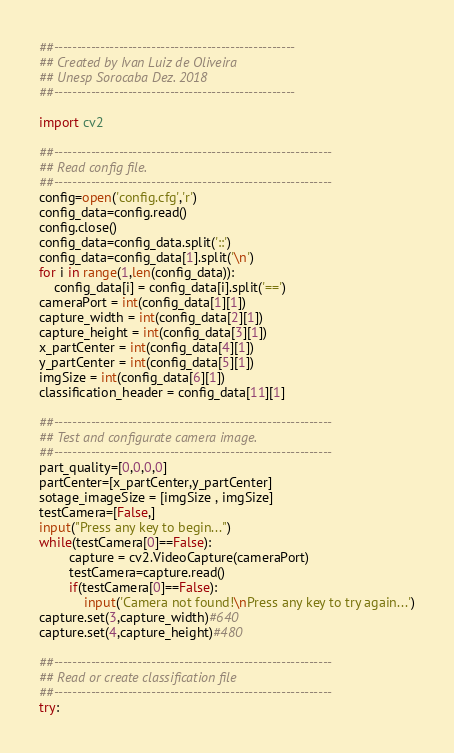Convert code to text. <code><loc_0><loc_0><loc_500><loc_500><_Python_>##----------------------------------------------------
## Created by Ivan Luiz de Oliveira
## Unesp Sorocaba Dez. 2018
##----------------------------------------------------

import cv2

##------------------------------------------------------------
## Read config file.
##------------------------------------------------------------
config=open('config.cfg','r')
config_data=config.read()
config.close()
config_data=config_data.split('::')
config_data=config_data[1].split('\n')
for i in range(1,len(config_data)):
    config_data[i] = config_data[i].split('==')
cameraPort = int(config_data[1][1])
capture_width = int(config_data[2][1])
capture_height = int(config_data[3][1])
x_partCenter = int(config_data[4][1])
y_partCenter = int(config_data[5][1])
imgSize = int(config_data[6][1])
classification_header = config_data[11][1]

##------------------------------------------------------------
## Test and configurate camera image.
##------------------------------------------------------------
part_quality=[0,0,0,0]
partCenter=[x_partCenter,y_partCenter]
sotage_imageSize = [imgSize , imgSize]
testCamera=[False,]
input("Press any key to begin...")
while(testCamera[0]==False):
        capture = cv2.VideoCapture(cameraPort)
        testCamera=capture.read()
        if(testCamera[0]==False):        
            input('Camera not found!\nPress any key to try again...')
capture.set(3,capture_width)#640
capture.set(4,capture_height)#480

##------------------------------------------------------------
## Read or create classification file
##------------------------------------------------------------
try:</code> 